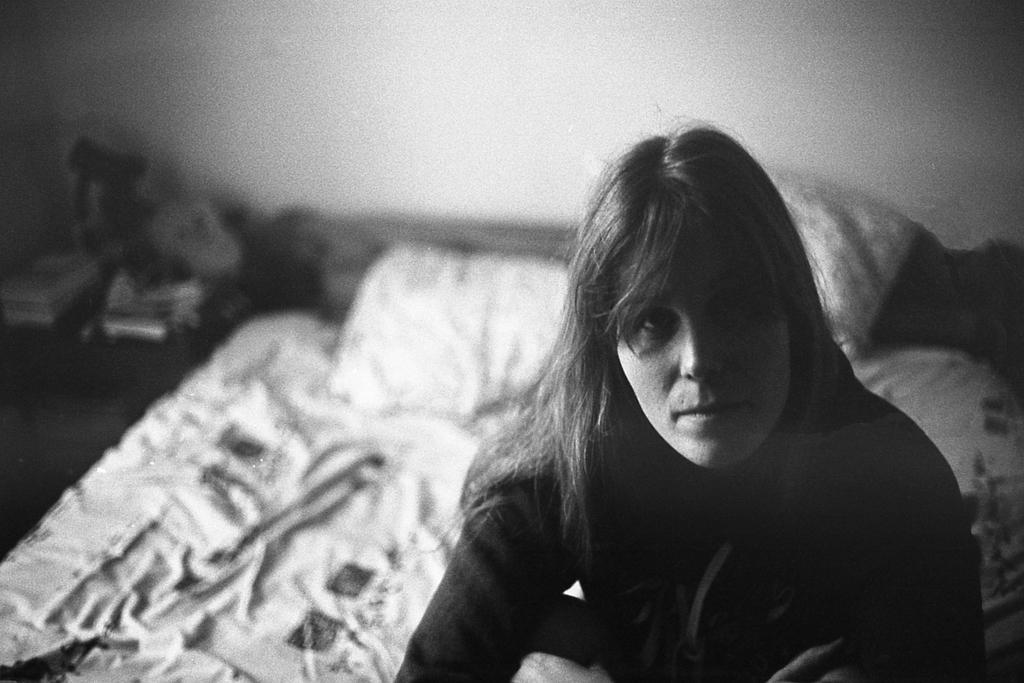What is the lady in the image doing? The lady is sitting on a bed in the image. Where was the image taken? The image was taken inside a house. What can be seen on the left side of the image? There are objects on a table to the left side of the image. What type of silk is the lady wearing in the image? There is no mention of silk or any specific clothing in the image, so it cannot be determined what the lady is wearing. 